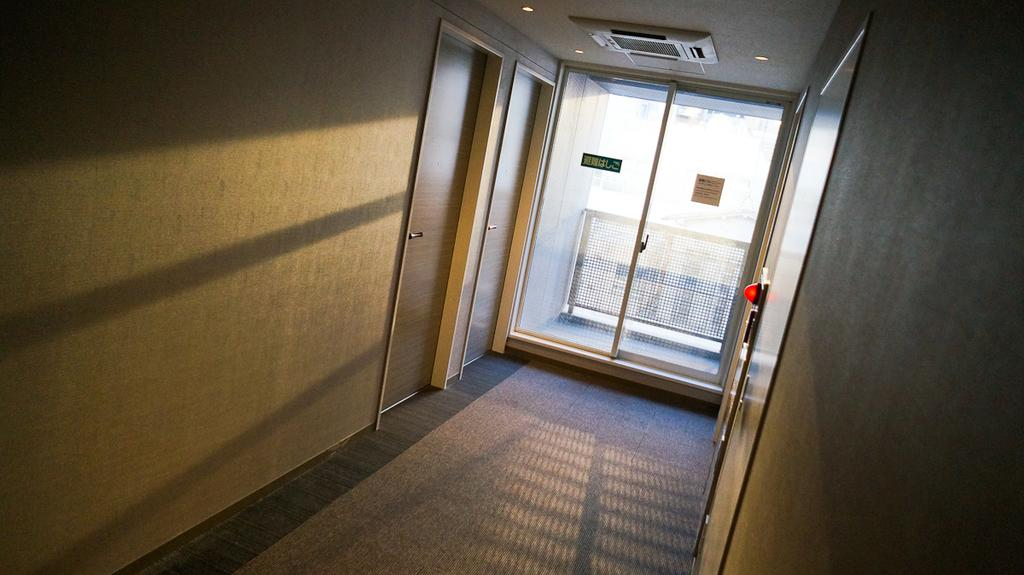What type of outdoor space is visible in the image? There is a veranda in the image. How many doors are present on the veranda? There are doors on the left and right sides of the veranda. What can be seen in the background of the image? There is another backdrop in the image. Are there any additional doors in the image? Yes, there is another door in the image. What type of architectural feature is present in the image? There is a balcony in the image. What color is the robin sitting on the marble in the image? There is no robin or marble present in the image. How does the throat of the person in the image feel? There is no person in the image, so we cannot determine how their throat feels. 